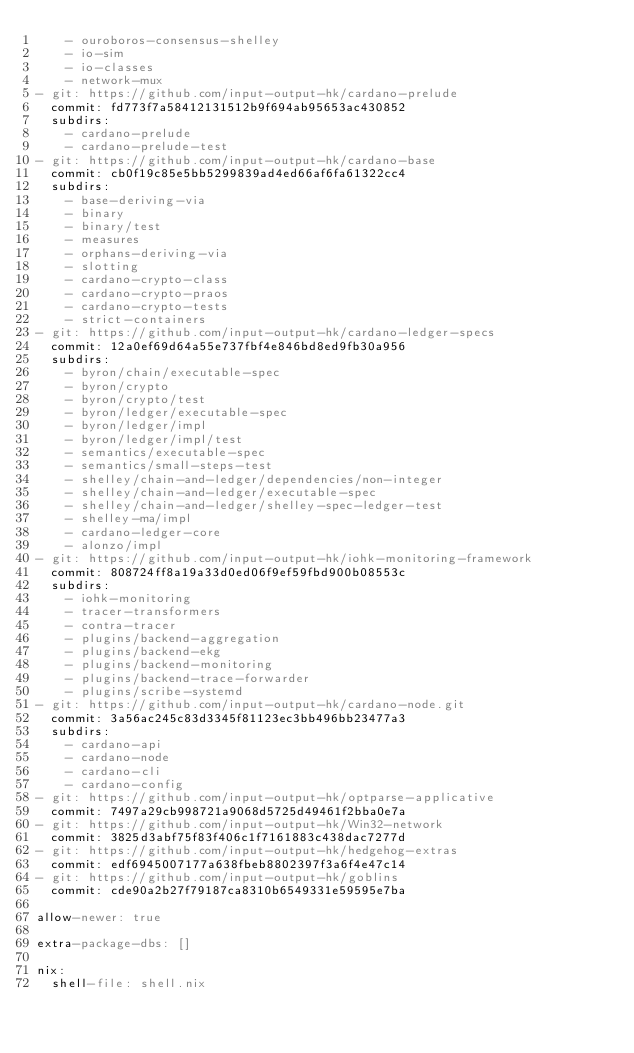<code> <loc_0><loc_0><loc_500><loc_500><_YAML_>    - ouroboros-consensus-shelley
    - io-sim
    - io-classes
    - network-mux
- git: https://github.com/input-output-hk/cardano-prelude
  commit: fd773f7a58412131512b9f694ab95653ac430852
  subdirs:
    - cardano-prelude
    - cardano-prelude-test
- git: https://github.com/input-output-hk/cardano-base
  commit: cb0f19c85e5bb5299839ad4ed66af6fa61322cc4
  subdirs:
    - base-deriving-via
    - binary
    - binary/test
    - measures
    - orphans-deriving-via
    - slotting
    - cardano-crypto-class
    - cardano-crypto-praos
    - cardano-crypto-tests
    - strict-containers
- git: https://github.com/input-output-hk/cardano-ledger-specs
  commit: 12a0ef69d64a55e737fbf4e846bd8ed9fb30a956
  subdirs:
    - byron/chain/executable-spec
    - byron/crypto
    - byron/crypto/test
    - byron/ledger/executable-spec
    - byron/ledger/impl
    - byron/ledger/impl/test
    - semantics/executable-spec
    - semantics/small-steps-test
    - shelley/chain-and-ledger/dependencies/non-integer
    - shelley/chain-and-ledger/executable-spec
    - shelley/chain-and-ledger/shelley-spec-ledger-test
    - shelley-ma/impl
    - cardano-ledger-core
    - alonzo/impl
- git: https://github.com/input-output-hk/iohk-monitoring-framework
  commit: 808724ff8a19a33d0ed06f9ef59fbd900b08553c
  subdirs:
    - iohk-monitoring
    - tracer-transformers
    - contra-tracer
    - plugins/backend-aggregation
    - plugins/backend-ekg
    - plugins/backend-monitoring
    - plugins/backend-trace-forwarder
    - plugins/scribe-systemd
- git: https://github.com/input-output-hk/cardano-node.git
  commit: 3a56ac245c83d3345f81123ec3bb496bb23477a3
  subdirs:
    - cardano-api
    - cardano-node
    - cardano-cli
    - cardano-config
- git: https://github.com/input-output-hk/optparse-applicative
  commit: 7497a29cb998721a9068d5725d49461f2bba0e7a
- git: https://github.com/input-output-hk/Win32-network
  commit: 3825d3abf75f83f406c1f7161883c438dac7277d
- git: https://github.com/input-output-hk/hedgehog-extras
  commit: edf6945007177a638fbeb8802397f3a6f4e47c14
- git: https://github.com/input-output-hk/goblins
  commit: cde90a2b27f79187ca8310b6549331e59595e7ba

allow-newer: true

extra-package-dbs: []

nix:
  shell-file: shell.nix
</code> 